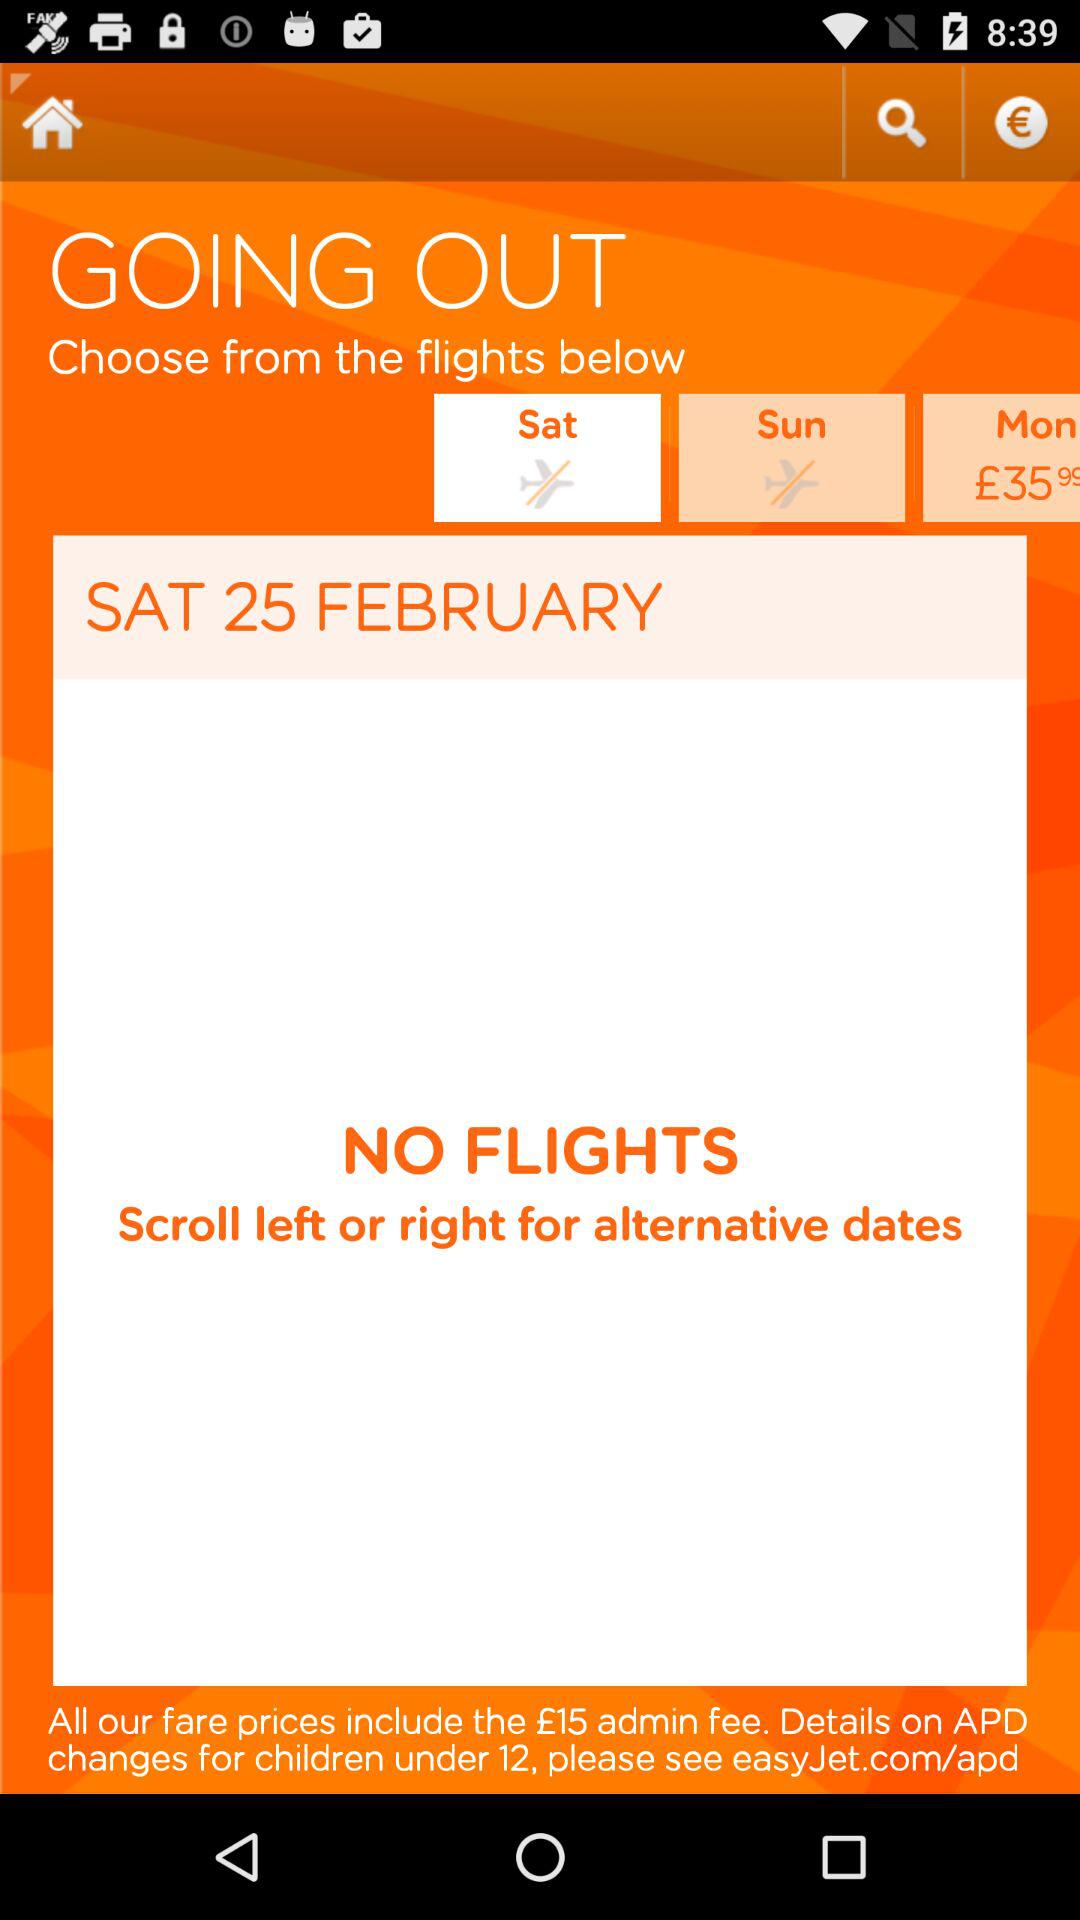What is the ticket price of a Monday flight?
When the provided information is insufficient, respond with <no answer>. <no answer> 